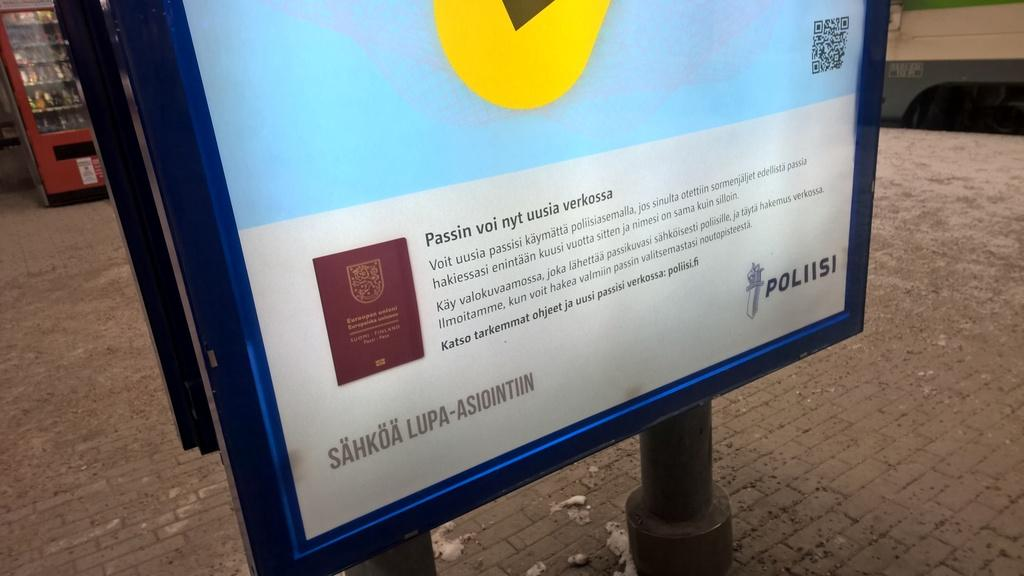<image>
Provide a brief description of the given image. A sign with information says "POLIISI" in the lower right corner. 